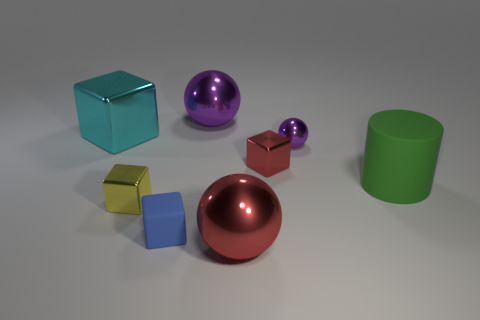Add 1 small yellow shiny cubes. How many objects exist? 9 Subtract all yellow blocks. How many purple balls are left? 2 Subtract all big spheres. How many spheres are left? 1 Subtract 1 cubes. How many cubes are left? 3 Subtract all cyan cubes. How many cubes are left? 3 Subtract all cylinders. How many objects are left? 7 Subtract all large cyan blocks. Subtract all large red shiny objects. How many objects are left? 6 Add 5 rubber cylinders. How many rubber cylinders are left? 6 Add 2 large green shiny cylinders. How many large green shiny cylinders exist? 2 Subtract 1 purple balls. How many objects are left? 7 